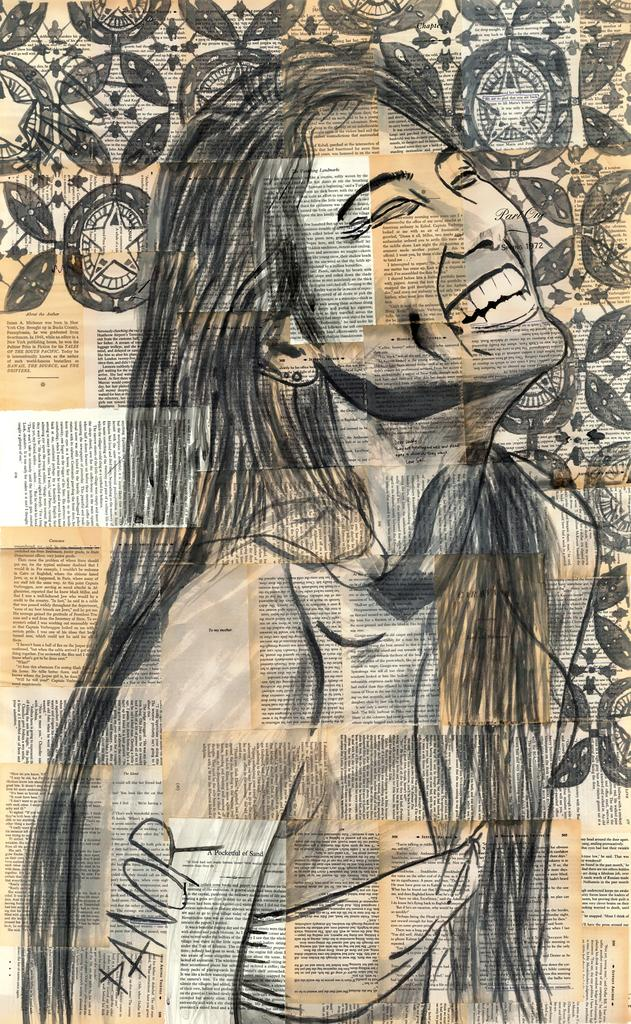<image>
Provide a brief description of the given image. An artwork of a woman shows the word Panor on her arm. 